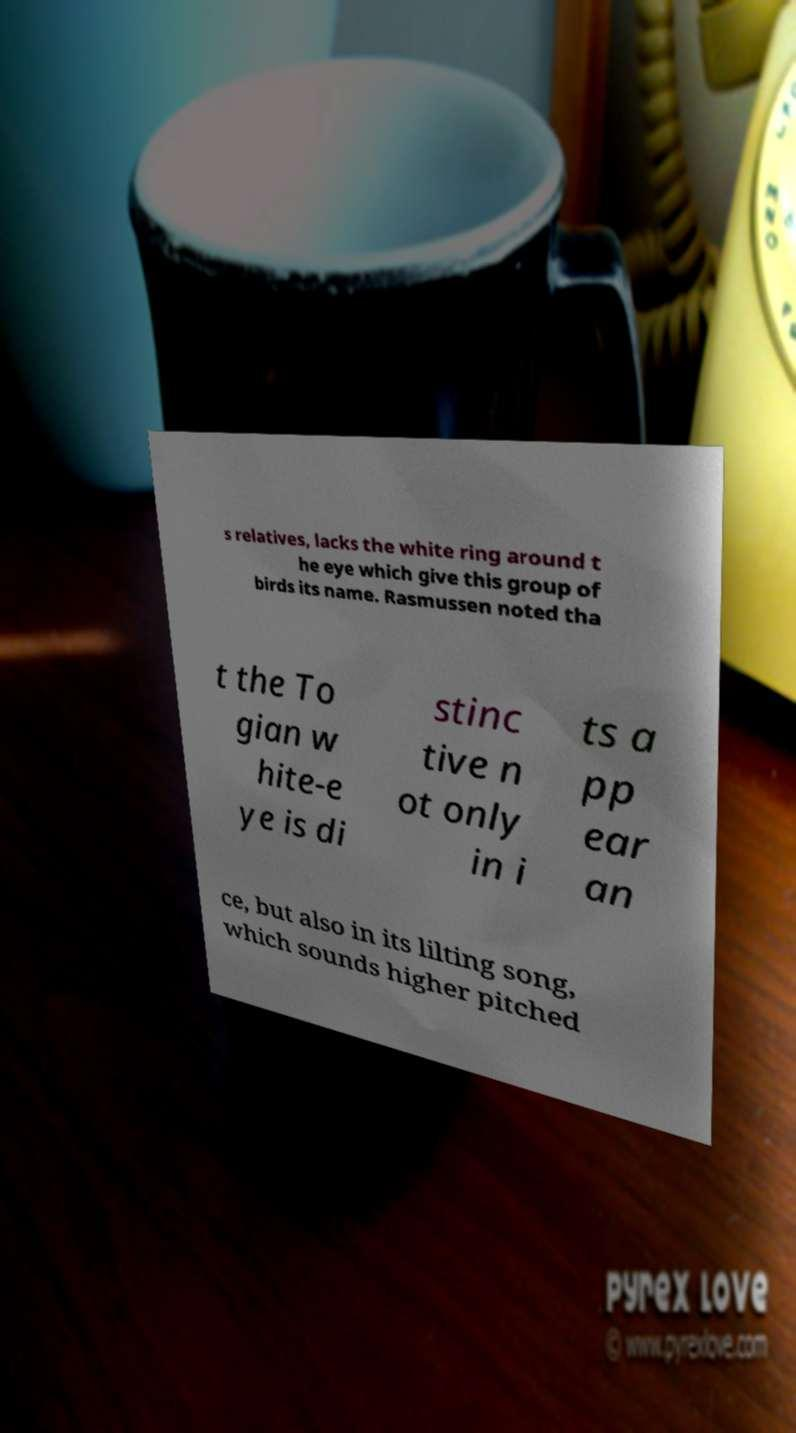Can you read and provide the text displayed in the image?This photo seems to have some interesting text. Can you extract and type it out for me? s relatives, lacks the white ring around t he eye which give this group of birds its name. Rasmussen noted tha t the To gian w hite-e ye is di stinc tive n ot only in i ts a pp ear an ce, but also in its lilting song, which sounds higher pitched 